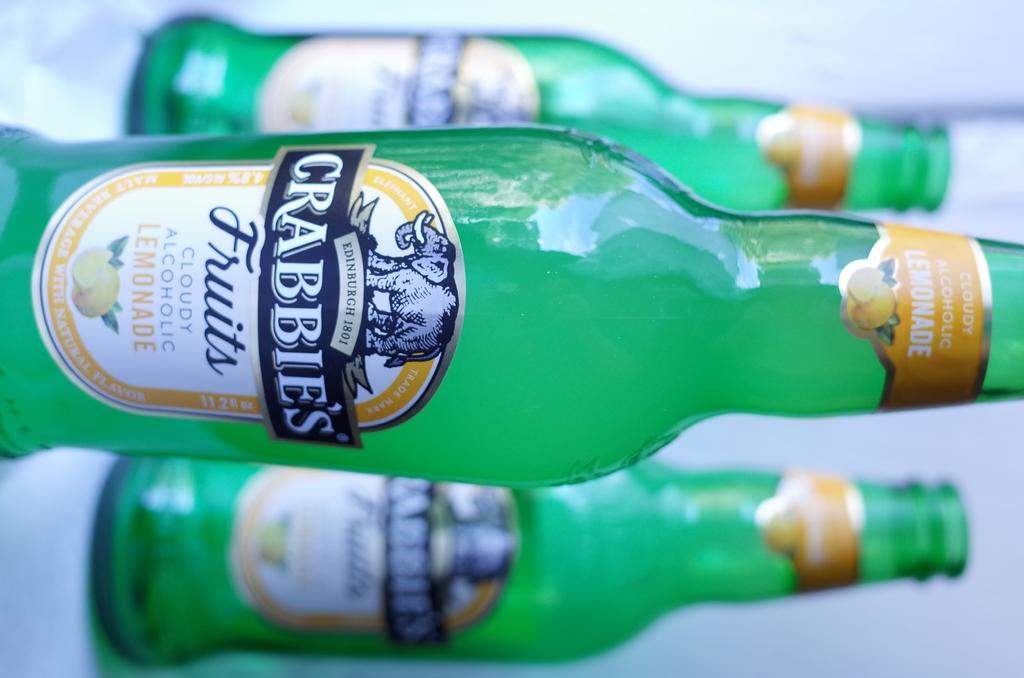What brand is this drink?
Your answer should be compact. Crabbie's. What flavor is this drink?
Keep it short and to the point. Lemonade. 